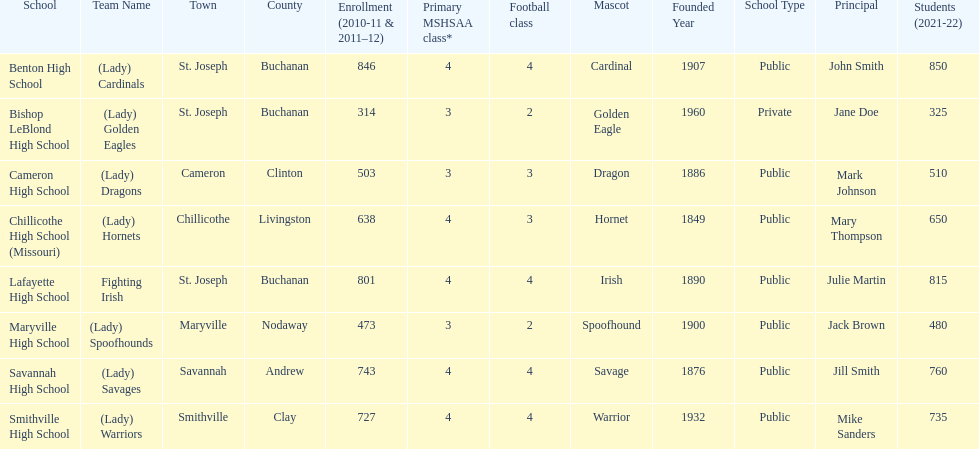Which school has the least amount of student enrollment between 2010-2011 and 2011-2012? Bishop LeBlond High School. 